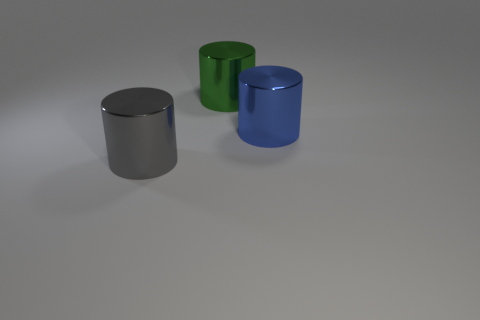Can you describe the surface that the cylinders are resting on? The cylinders are resting on a flat, matte surface that appears to be slightly textured. It contrasts with the shiny texture of the cylinders, emphasizing their reflective qualities. Would you say the surface contributes to the overall aesthetic of the image? Absolutely, the subtle texture of the surface adds depth to the composition and provides a visual balance against the high gloss of the metal cylinders, enhancing the image's minimalist aesthetic. 